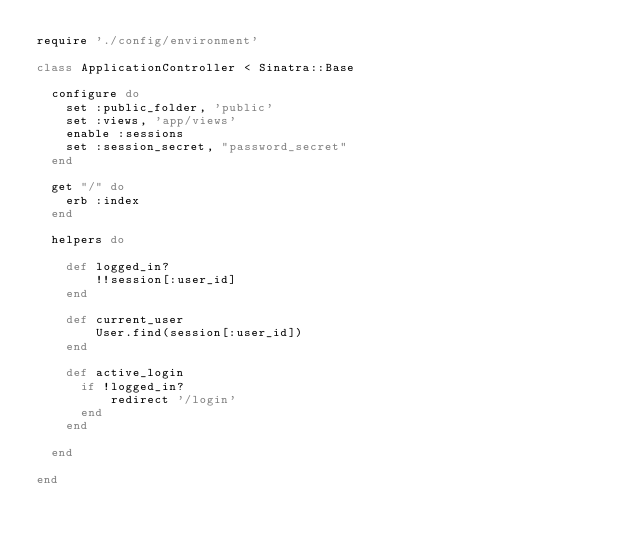<code> <loc_0><loc_0><loc_500><loc_500><_Ruby_>require './config/environment'

class ApplicationController < Sinatra::Base

  configure do
    set :public_folder, 'public'
    set :views, 'app/views'
    enable :sessions
		set :session_secret, "password_secret"
  end

  get "/" do
    erb :index
  end

  helpers do 
        
    def logged_in?
        !!session[:user_id]
    end 

    def current_user 
        User.find(session[:user_id]) 
    end 

    def active_login
      if !logged_in?
          redirect '/login'
      end 
    end 

  end 

end
</code> 